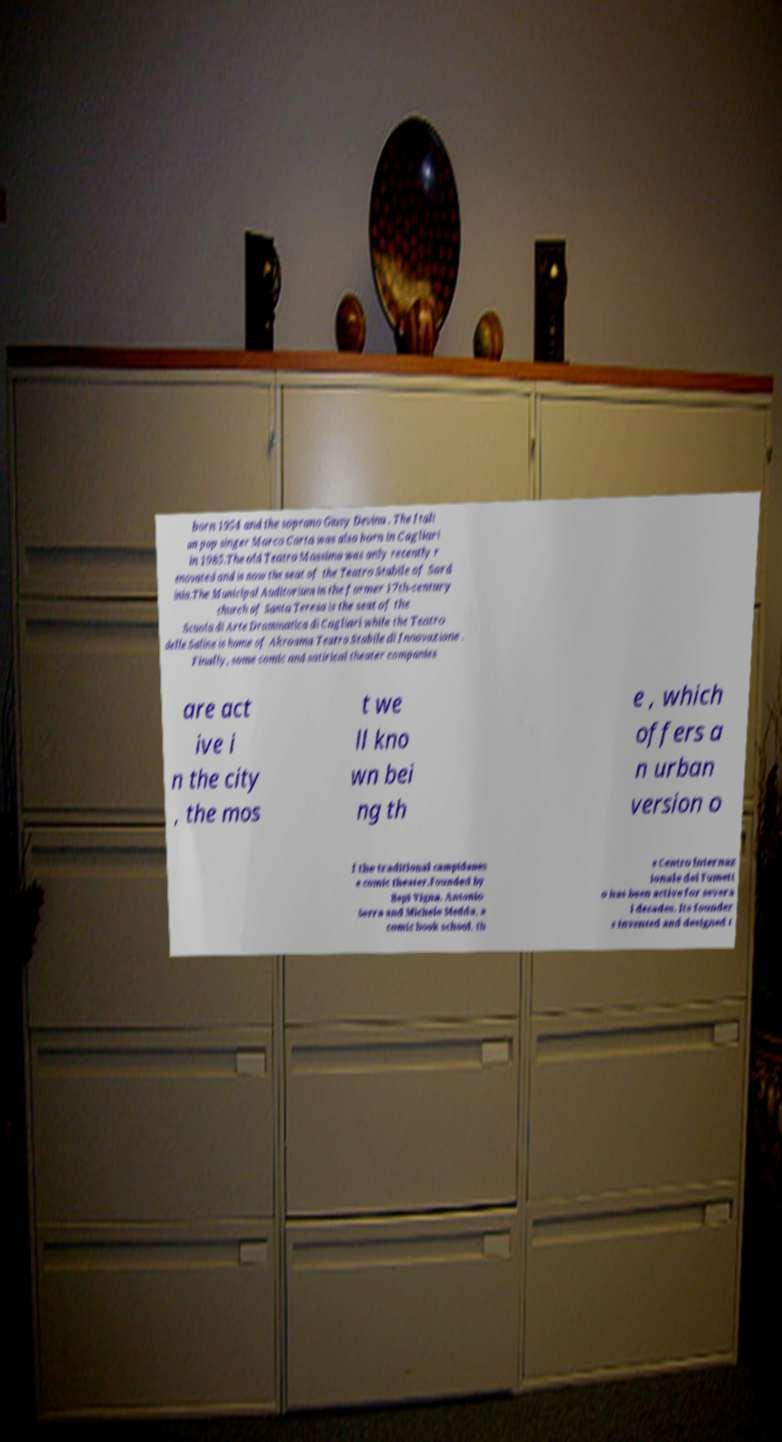There's text embedded in this image that I need extracted. Can you transcribe it verbatim? born 1954 and the soprano Giusy Devinu . The Itali an pop singer Marco Carta was also born in Cagliari in 1985.The old Teatro Massimo was only recently r enovated and is now the seat of the Teatro Stabile of Sard inia.The Municipal Auditorium in the former 17th-century church of Santa Teresa is the seat of the Scuola di Arte Drammatica di Cagliari while the Teatro delle Saline is home of Akroama Teatro Stabile di Innovazione . Finally, some comic and satirical theater companies are act ive i n the city , the mos t we ll kno wn bei ng th e , which offers a n urban version o f the traditional campidanes e comic theater.Founded by Bepi Vigna, Antonio Serra and Michele Medda, a comic book school, th e Centro Internaz ionale del Fumett o has been active for severa l decades. Its founder s invented and designed t 